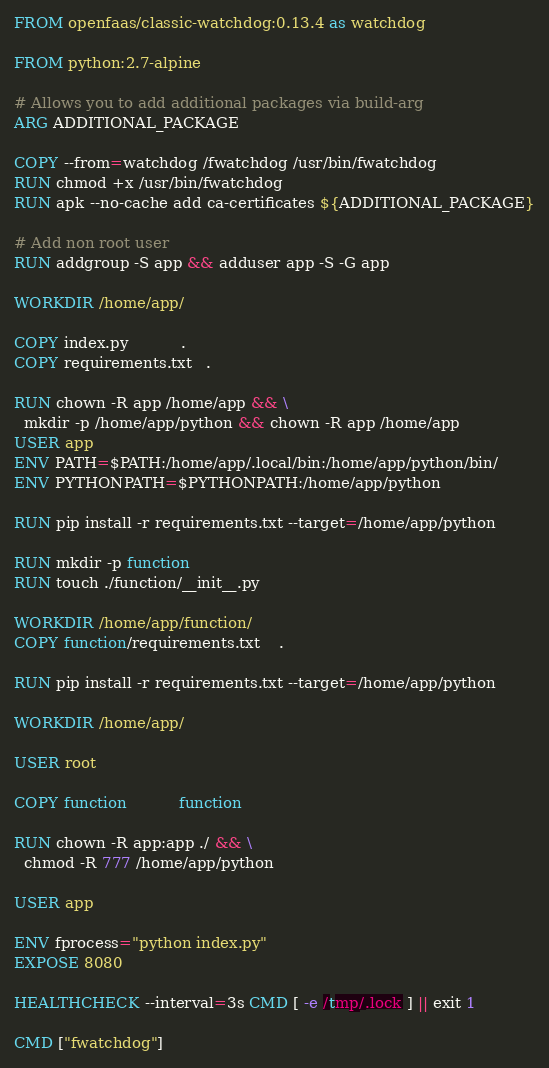<code> <loc_0><loc_0><loc_500><loc_500><_Dockerfile_>FROM openfaas/classic-watchdog:0.13.4 as watchdog

FROM python:2.7-alpine

# Allows you to add additional packages via build-arg
ARG ADDITIONAL_PACKAGE

COPY --from=watchdog /fwatchdog /usr/bin/fwatchdog
RUN chmod +x /usr/bin/fwatchdog
RUN apk --no-cache add ca-certificates ${ADDITIONAL_PACKAGE}

# Add non root user
RUN addgroup -S app && adduser app -S -G app

WORKDIR /home/app/

COPY index.py           .
COPY requirements.txt   .

RUN chown -R app /home/app && \
  mkdir -p /home/app/python && chown -R app /home/app
USER app
ENV PATH=$PATH:/home/app/.local/bin:/home/app/python/bin/
ENV PYTHONPATH=$PYTHONPATH:/home/app/python

RUN pip install -r requirements.txt --target=/home/app/python

RUN mkdir -p function
RUN touch ./function/__init__.py

WORKDIR /home/app/function/
COPY function/requirements.txt	.

RUN pip install -r requirements.txt --target=/home/app/python

WORKDIR /home/app/

USER root

COPY function           function

RUN chown -R app:app ./ && \
  chmod -R 777 /home/app/python

USER app

ENV fprocess="python index.py"
EXPOSE 8080

HEALTHCHECK --interval=3s CMD [ -e /tmp/.lock ] || exit 1

CMD ["fwatchdog"]
</code> 